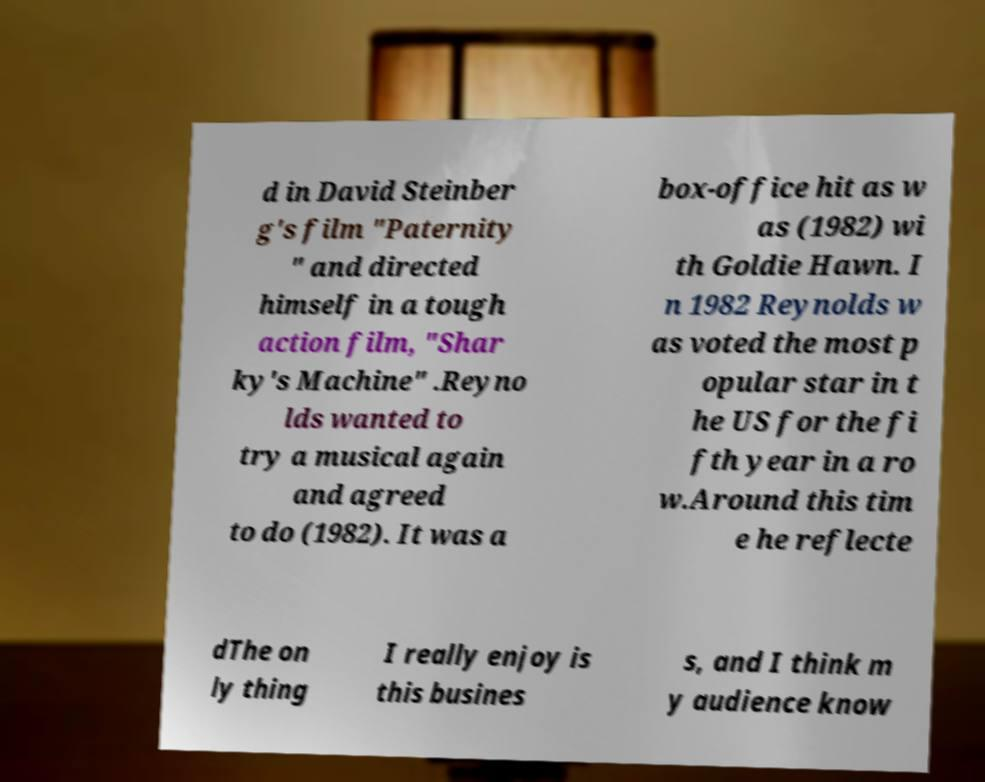Can you accurately transcribe the text from the provided image for me? d in David Steinber g's film "Paternity " and directed himself in a tough action film, "Shar ky's Machine" .Reyno lds wanted to try a musical again and agreed to do (1982). It was a box-office hit as w as (1982) wi th Goldie Hawn. I n 1982 Reynolds w as voted the most p opular star in t he US for the fi fth year in a ro w.Around this tim e he reflecte dThe on ly thing I really enjoy is this busines s, and I think m y audience know 